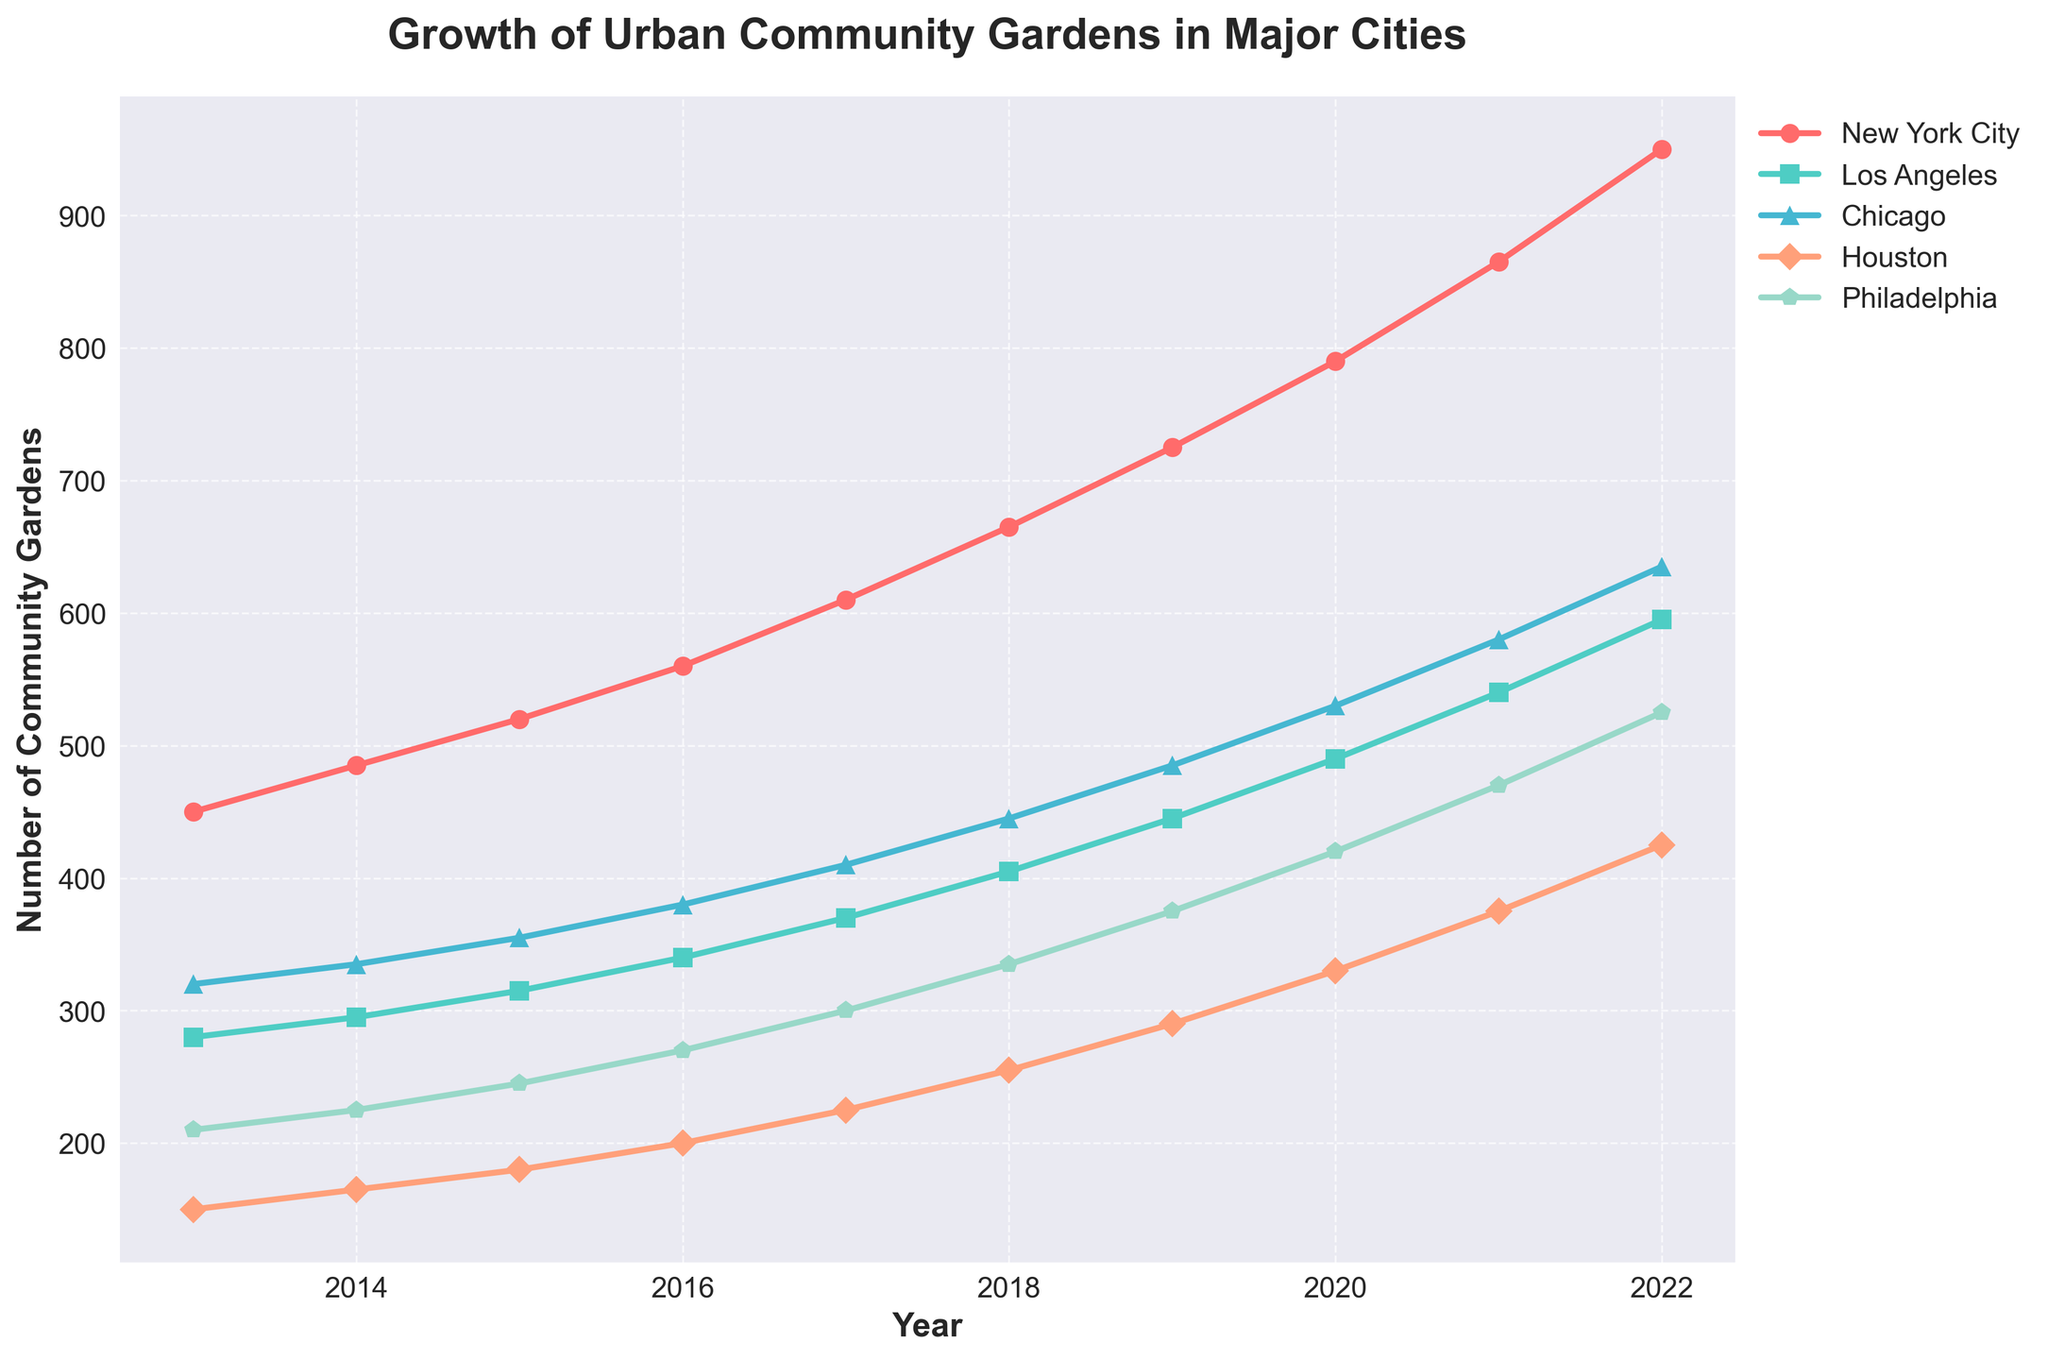Which city had the highest number of community gardens in 2022? Look at the end points for each city's line on the x-axis corresponding to the year 2022. Identify the line with the highest y-value.
Answer: New York City What is the average yearly increase in the number of community gardens in Los Angeles from 2013 to 2022? Find the difference in the number of gardens between 2022 and 2013 for Los Angeles, then divide by the number of years (2022-2013 = 9). (595 - 280) / 9 = 35
Answer: 35 Which city saw the smallest increase in community gardens from 2013 to 2022? Calculate the difference in the number of gardens between 2022 and 2013 for each city. Compare these differences to see which is the smallest. Houston: 425-150 = 275, which is smaller than other cities.
Answer: Houston In which year did New York City reach over 600 community gardens? Look along the New York City line to see where it first crosses the 600 mark on the y-axis. This occurs between 2016 and 2017. Exactly, in 2017.
Answer: 2017 By how many community gardens did Chicago increase from 2015 to 2019? Find the number of community gardens in Chicago for the years 2015 and 2019, then subtract the former from the latter. 485 - 355 = 130
Answer: 130 Which two cities had the closest number of community gardens in 2018? Compare the y-values of the different cities' lines at the year 2018 to see which two are most similar. Chicago (445) and Philadelphia (335). Difference = 445-335=110, so it's New York City (665) and Los Angeles (405), difference = 665-405=260. Actually difference of 110 is smaller.
Answer: Chicago and Philadelphia What colors are used to represent New York City and Houston, respectively? Examine the legend to identify which colors correspond to New York City and Houston. New York City is represented by red, and Houston is represented by orange.
Answer: Red and Orange In which year did Philadelphia surpass 400 community gardens? Examine the Philadelphia line to see at which year it crosses the 400 mark on the y-axis. This occurs between 2020 and 2021. Exactly in 2021.
Answer: 2021 For which city does the line appear to have the steepest slope between 2019 and 2020? Check the lines between the years 2019 and 2020 and visually identify which one has the steepest incline. New York City shows the steepest increase.
Answer: New York City 